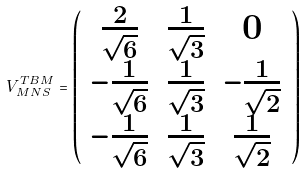<formula> <loc_0><loc_0><loc_500><loc_500>V _ { M N S } ^ { T B M } = \left ( \begin{array} { c c c } \frac { 2 } { \sqrt { 6 } } & \frac { 1 } { \sqrt { 3 } } & 0 \\ - \frac { 1 } { \sqrt { 6 } } & \frac { 1 } { \sqrt { 3 } } & - \frac { 1 } { \sqrt { 2 } } \\ - \frac { 1 } { \sqrt { 6 } } & \frac { 1 } { \sqrt { 3 } } & \frac { 1 } { \sqrt { 2 } } \end{array} \right )</formula> 